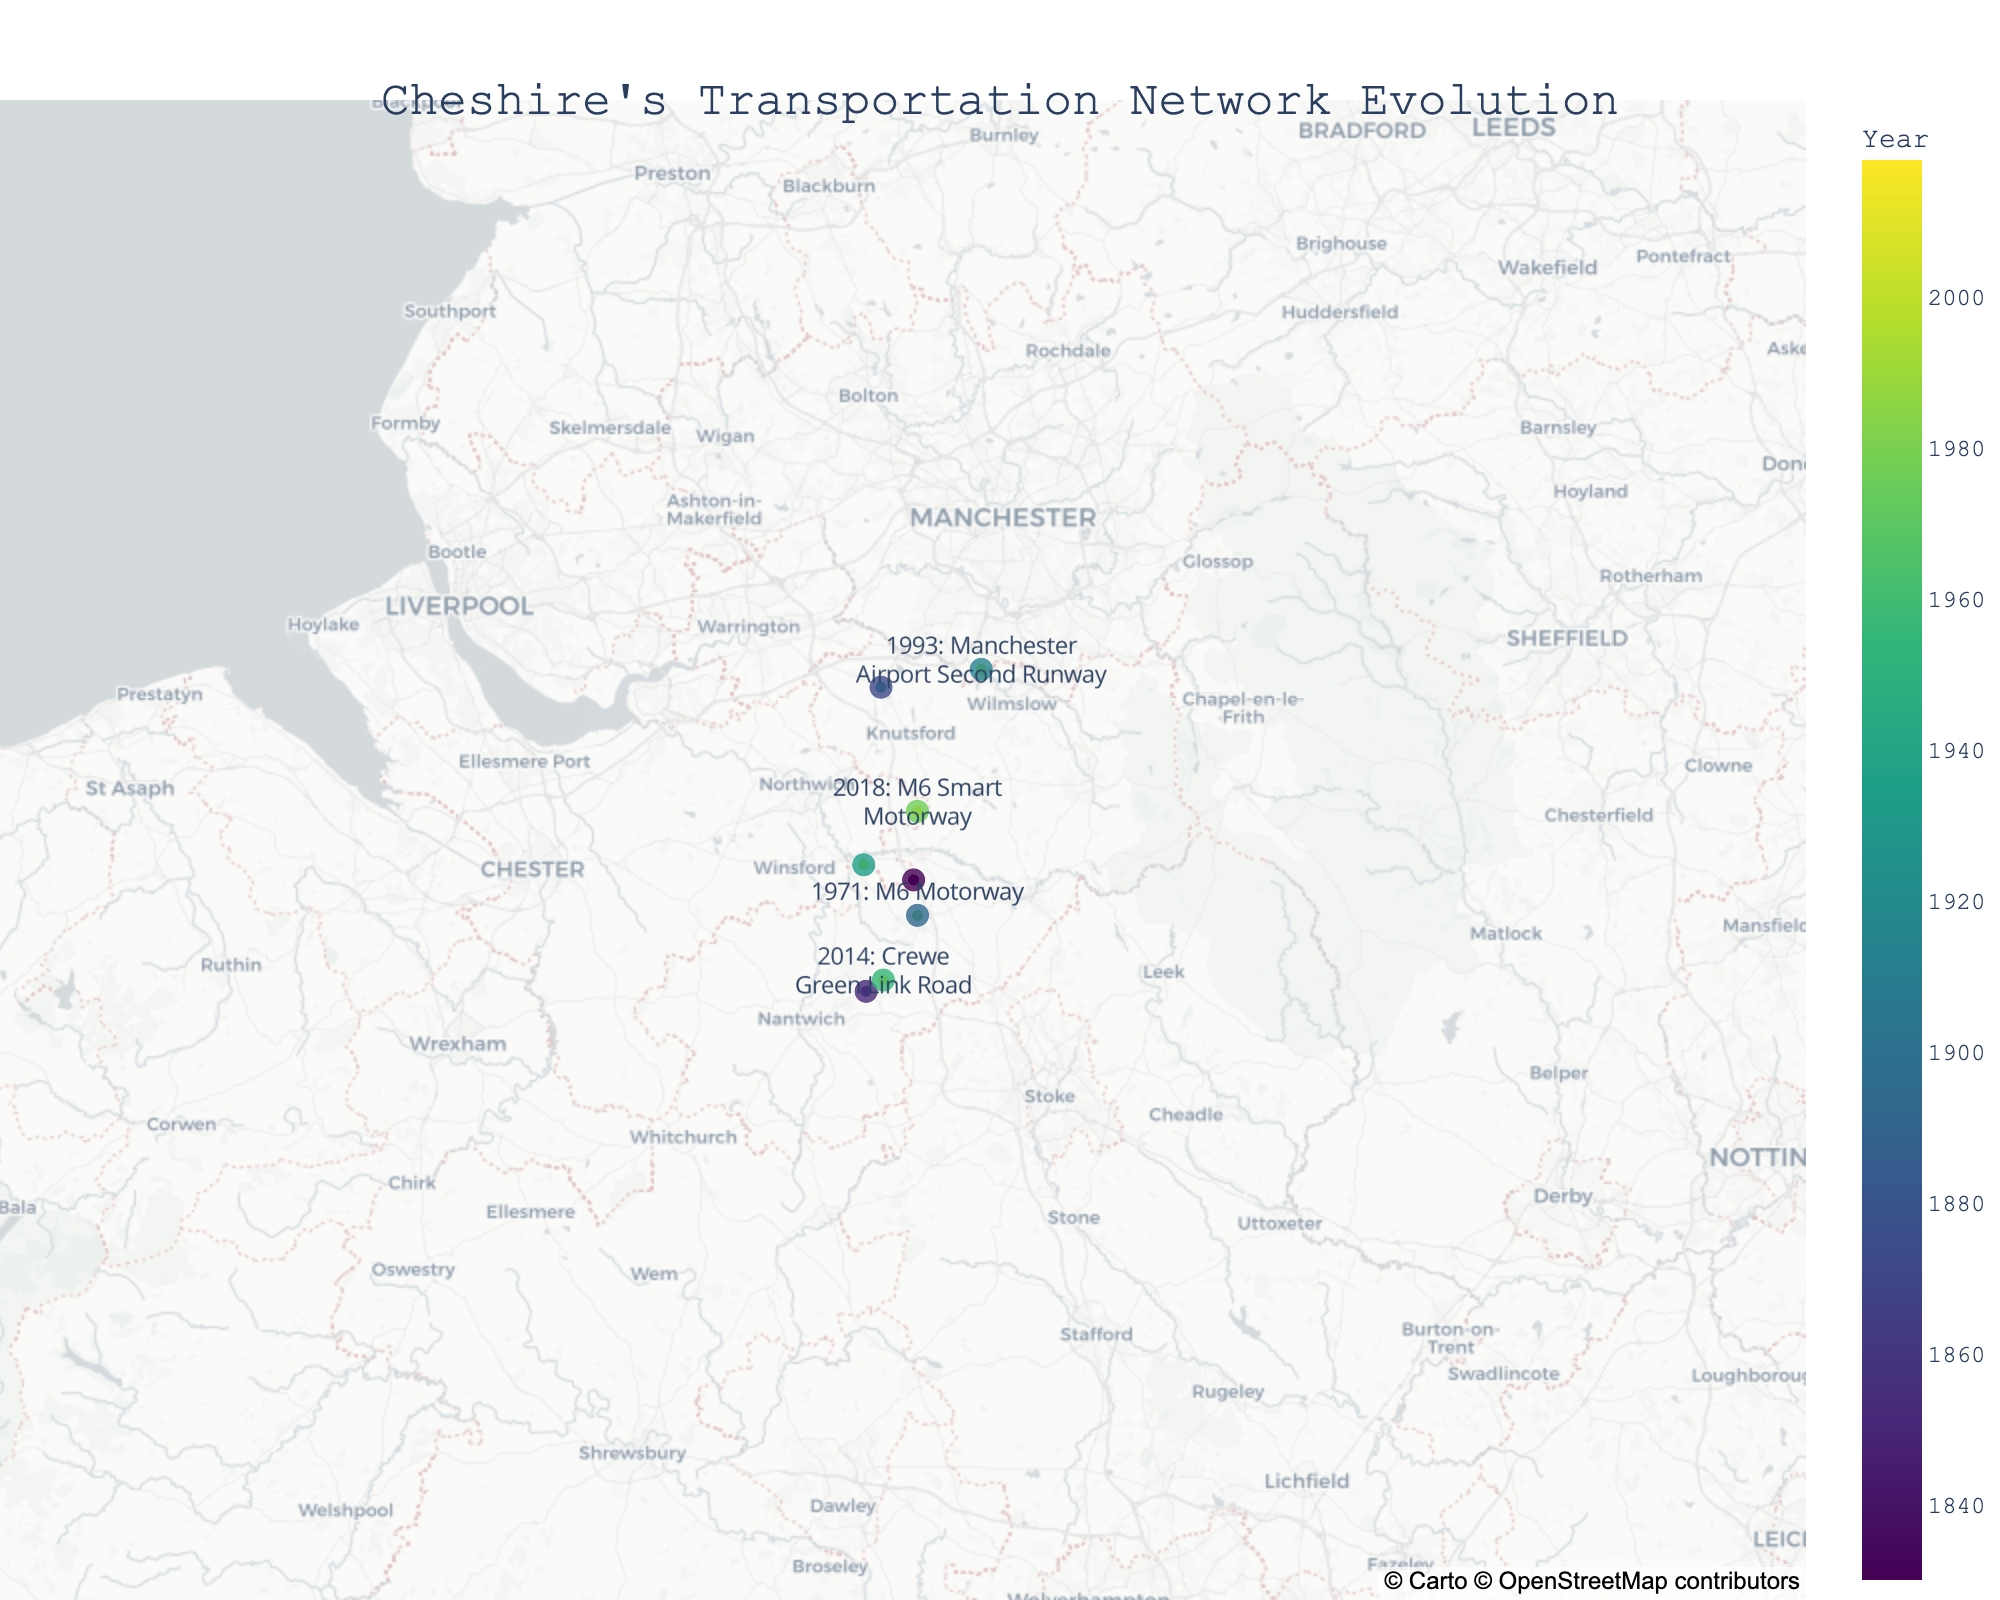How many transportation projects are depicted in the figure? There are markers representing each transportation project on the map. By counting them, we find there are 8 projects in total.
Answer: 8 What is the title of the plot? The title is shown at the top center of the plot and reads "Cheshire's Transportation Network Evolution".
Answer: Cheshire's Transportation Network Evolution Which project is located furthest north? By looking at the map, the project located furthest north is the "A556 Chester Road".
Answer: A556 Chester Road Which project was completed in the year 2003? The hover text for the markers includes the year of the project. The project completed in 2003 is the "Middlewich Eastern Bypass".
Answer: Middlewich Eastern Bypass What are the coordinates of the Crewe Railway Station? The map markers show the locations of the projects. The coordinates for the Crewe Railway Station are 53.0890 (latitude) and -2.4331 (longitude).
Answer: 53.0890, -2.4331 How many road-related projects are shown in the plot? By examining the descriptions of each project, we can identify that there are four road-related projects: A556 Chester Road, M6 Motorway, Middlewich Eastern Bypass, and Crewe Green Link Road.
Answer: 4 Which project involved the use of smart technology and in what year was it completed? Refer to the description provided in the marker to identify the project. The "M6 Smart Motorway" involved smart technology and was completed in 2018.
Answer: M6 Smart Motorway, 2018 How does the latitude of Manchester Airport Second Runway compare to the latitude of the Grand Junction Railway? By comparing the latitudes of both projects from the map, the latitude of Manchester Airport Second Runway (53.3537) is greater than that of Grand Junction Railway (53.1807).
Answer: Manchester Airport Second Runway has a higher latitude 